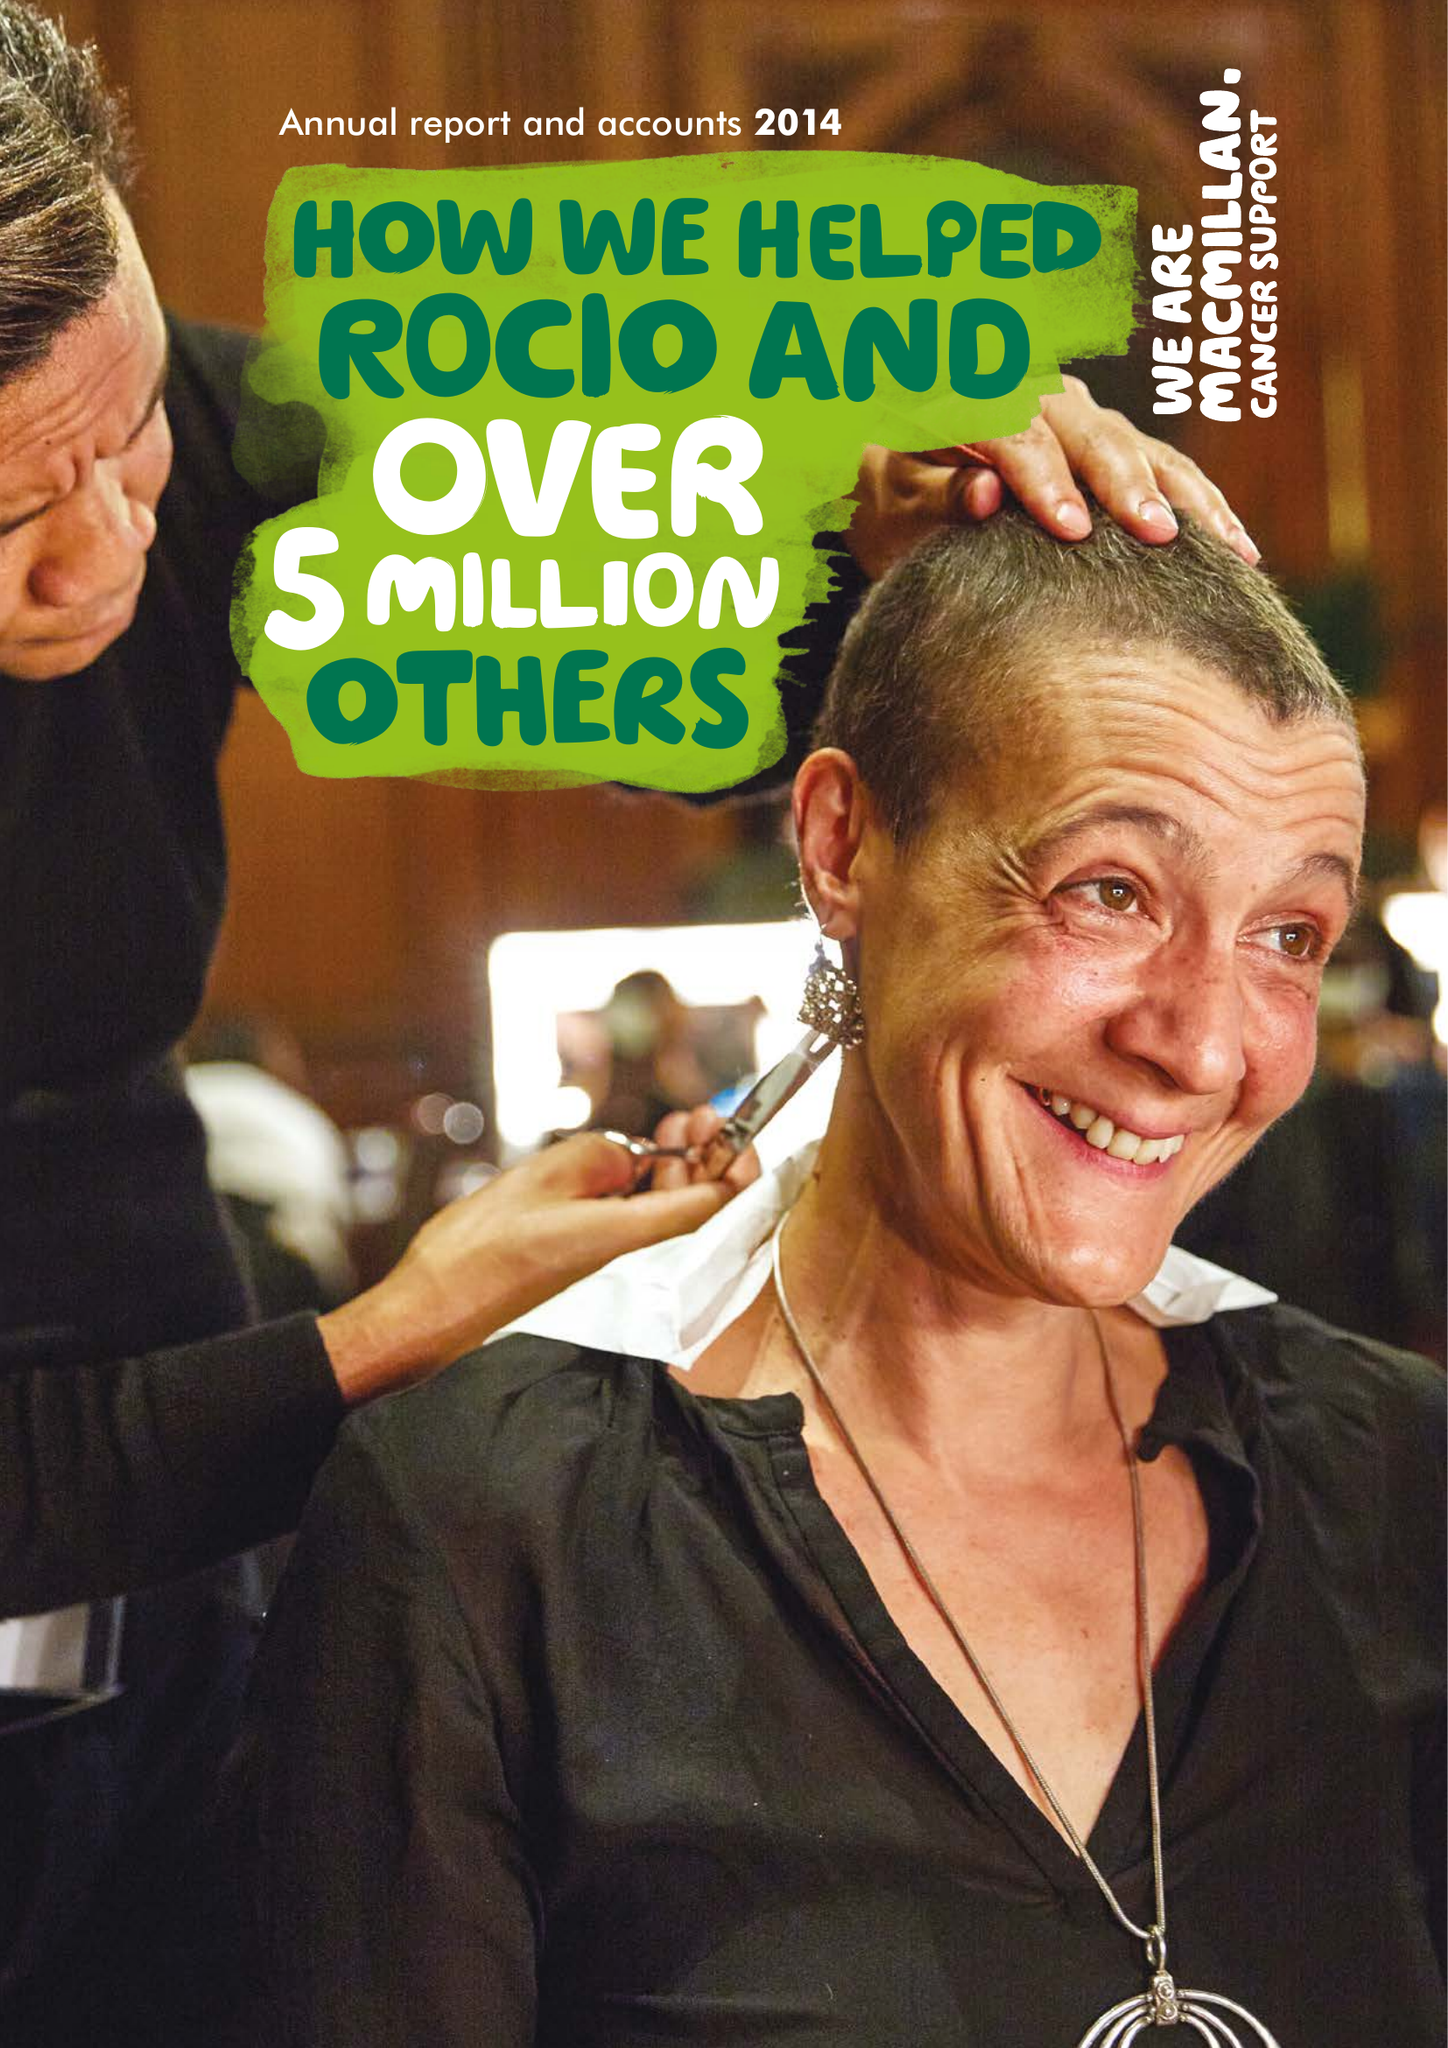What is the value for the address__postcode?
Answer the question using a single word or phrase. SE1 7UQ 